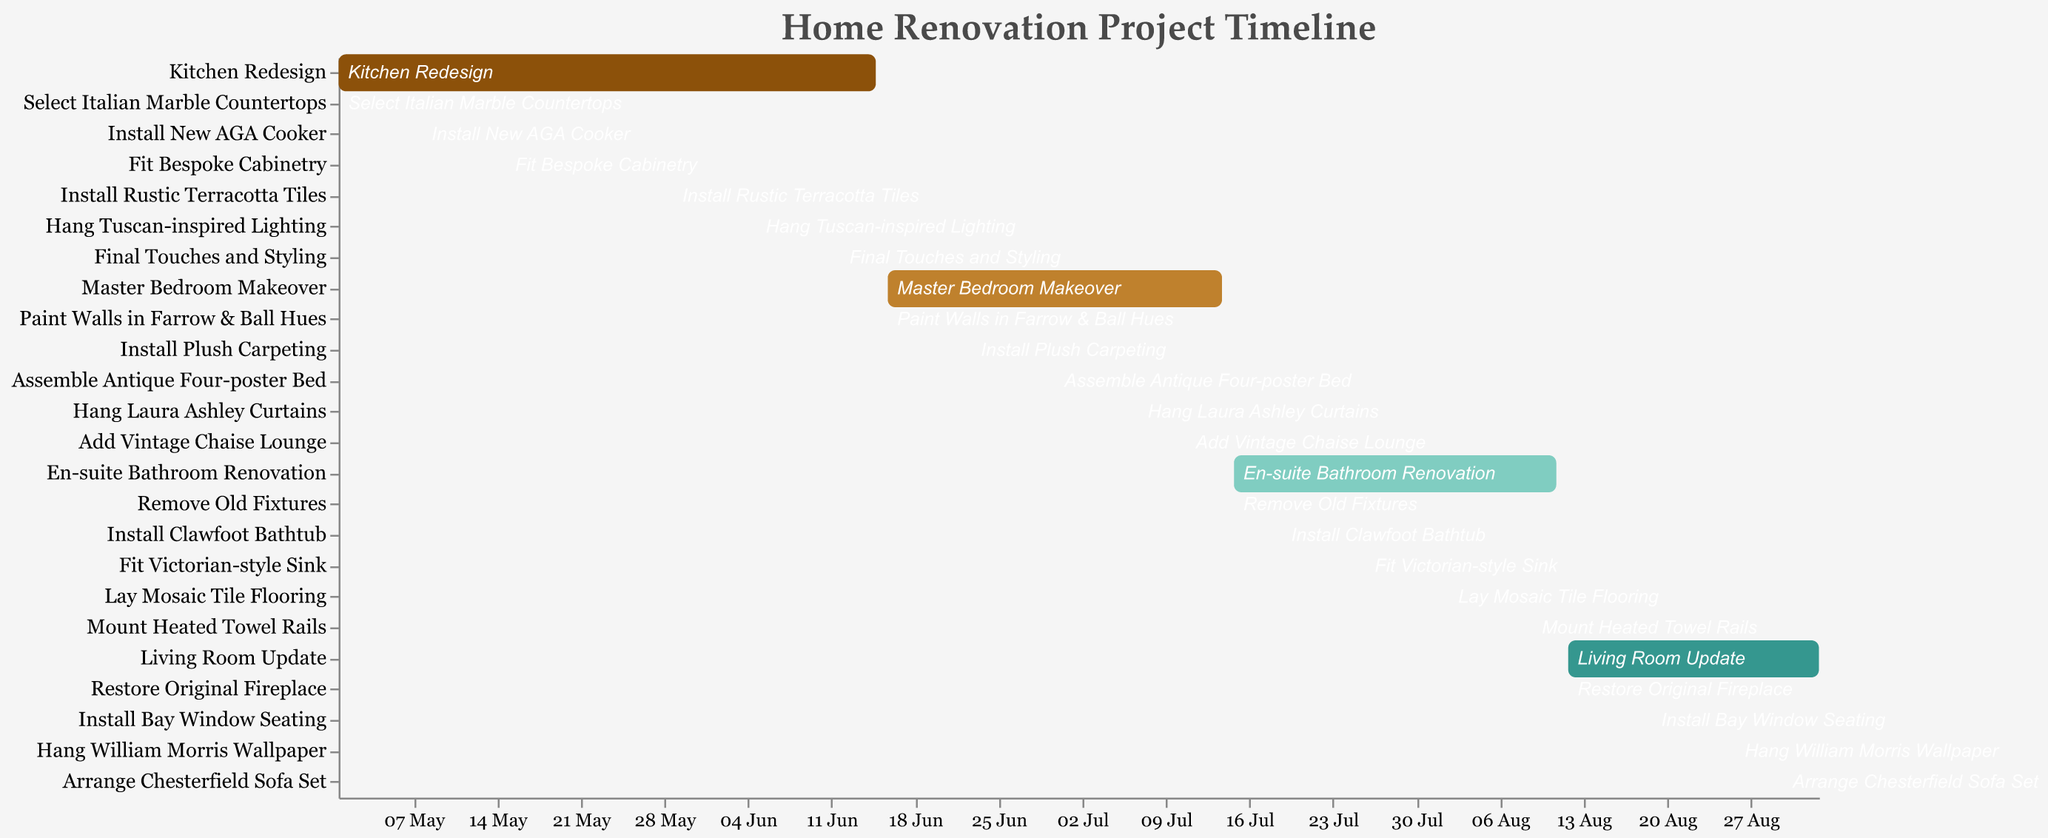What is the title of the project timeline? The title of the project timeline is displayed at the top of the chart.
Answer: Home Renovation Project Timeline Which task in the kitchen redesign starts first? The task 'Select Italian Marble Countertops' starts on 2023-05-01 which is the earliest start date for any task in the kitchen redesign.
Answer: Select Italian Marble Countertops How long does the 'Install Bay Window Seating' task take? The 'Install Bay Window Seating' task starts on 2023-08-19 and ends on 2023-08-25. The duration is calculated by counting the days between these dates.
Answer: 7 days Which room's renovation finishes last? By looking at the end dates of the final tasks for each room, it is observed that the Living Room Update's final task 'Arrange Chesterfield Sofa Set' ends on 2023-09-02, later than any other room's tasks.
Answer: Living Room Update Compare the duration of 'Master Bedroom Makeover' and 'En-suite Bathroom Renovation'. Which one is longer? The 'Master Bedroom Makeover' starts on 2023-06-16 and ends on 2023-07-14, lasting 29 days. The 'En-suite Bathroom Renovation' starts on 2023-07-15 and ends on 2023-08-11, lasting 28 days.
Answer: Master Bedroom Makeover How many major tasks (headline tasks) does the project include? There are four major tasks in the project, recognizable by their specific colors and italicized text in the Gantt chart. These are 'Kitchen Redesign,' 'Master Bedroom Makeover,' 'En-suite Bathroom Renovation,' and 'Living Room Update.'
Answer: 4 What is the total time span for the whole renovation project? The project starts with 'Select Italian Marble Countertops' on 2023-05-01 and ends with 'Arrange Chesterfield Sofa Set' on 2023-09-02. The duration between these dates marks the total time span.
Answer: 125 days During the Kitchen Redesign, which task immediately follows 'Install New AGA Cooker'? The task 'Fit Bespoke Cabinetry' starts on 2023-05-15, the day after 'Install New AGA Cooker' ends on 2023-05-14.
Answer: Fit Bespoke Cabinetry 